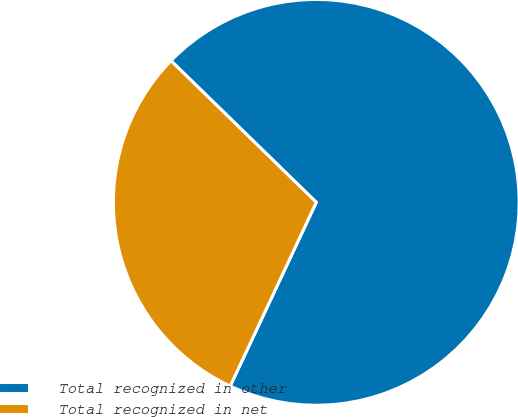Convert chart. <chart><loc_0><loc_0><loc_500><loc_500><pie_chart><fcel>Total recognized in other<fcel>Total recognized in net<nl><fcel>69.68%<fcel>30.32%<nl></chart> 